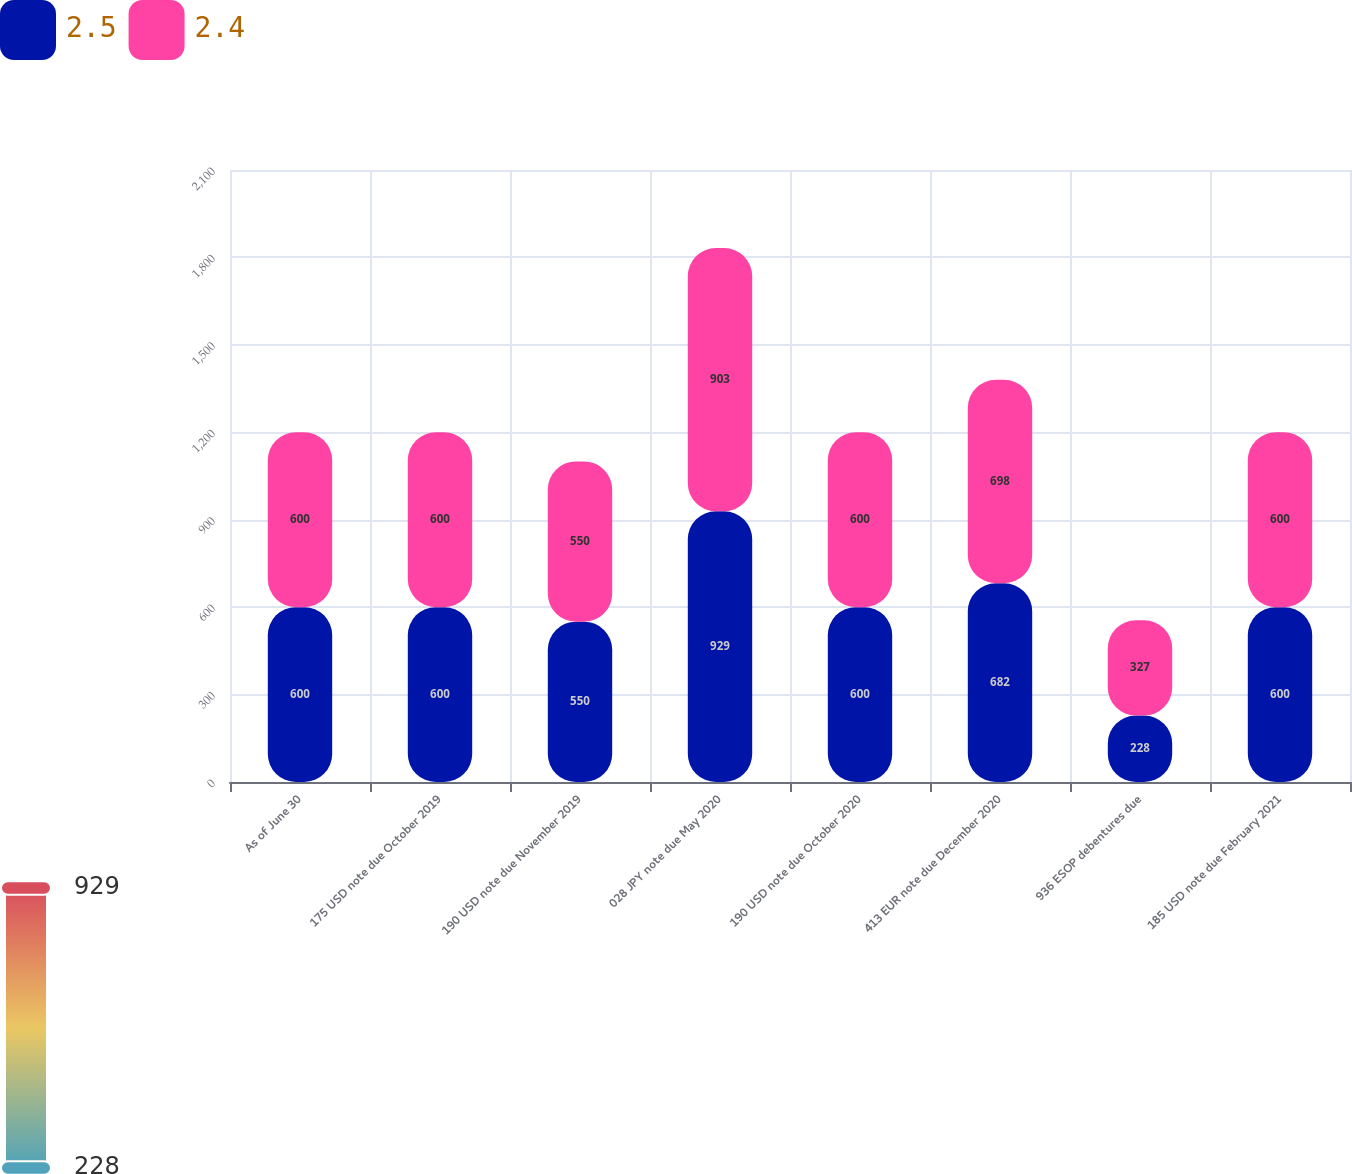Convert chart to OTSL. <chart><loc_0><loc_0><loc_500><loc_500><stacked_bar_chart><ecel><fcel>As of June 30<fcel>175 USD note due October 2019<fcel>190 USD note due November 2019<fcel>028 JPY note due May 2020<fcel>190 USD note due October 2020<fcel>413 EUR note due December 2020<fcel>936 ESOP debentures due<fcel>185 USD note due February 2021<nl><fcel>2.5<fcel>600<fcel>600<fcel>550<fcel>929<fcel>600<fcel>682<fcel>228<fcel>600<nl><fcel>2.4<fcel>600<fcel>600<fcel>550<fcel>903<fcel>600<fcel>698<fcel>327<fcel>600<nl></chart> 